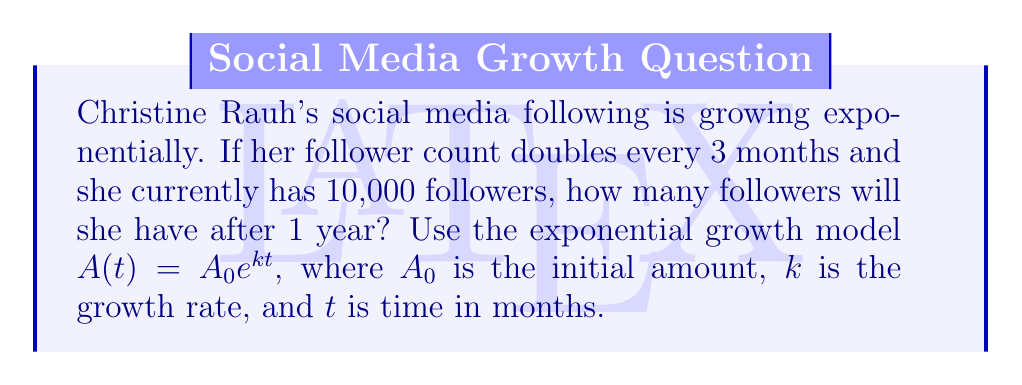Teach me how to tackle this problem. Let's approach this step-by-step:

1) We're given that the follower count doubles every 3 months. We can use this to find the growth rate $k$:

   $2 = e^{3k}$
   $\ln(2) = 3k$
   $k = \frac{\ln(2)}{3} \approx 0.2310$

2) Now we have all the components for our model:
   $A_0 = 10,000$ (initial followers)
   $k \approx 0.2310$ (growth rate per month)
   $t = 12$ (we want to know the count after 1 year = 12 months)

3) Let's plug these into our exponential growth model:

   $A(t) = A_0 e^{kt}$
   $A(12) = 10,000 \cdot e^{0.2310 \cdot 12}$

4) Calculating this:
   $A(12) = 10,000 \cdot e^{2.7720}$
   $A(12) = 10,000 \cdot 15.9974$
   $A(12) = 159,974$

5) Rounding to the nearest whole number (as we can't have fractional followers):
   $A(12) \approx 159,974$ followers
Answer: 159,974 followers 